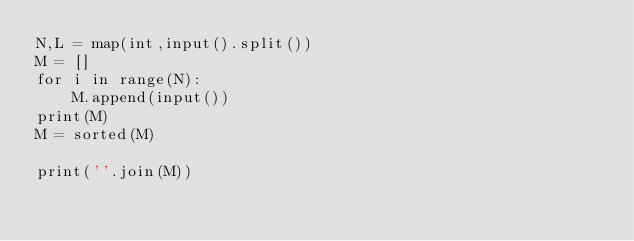<code> <loc_0><loc_0><loc_500><loc_500><_Python_>N,L = map(int,input().split())
M = []
for i in range(N):
    M.append(input())
print(M)
M = sorted(M)

print(''.join(M))</code> 